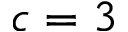Convert formula to latex. <formula><loc_0><loc_0><loc_500><loc_500>c = 3</formula> 